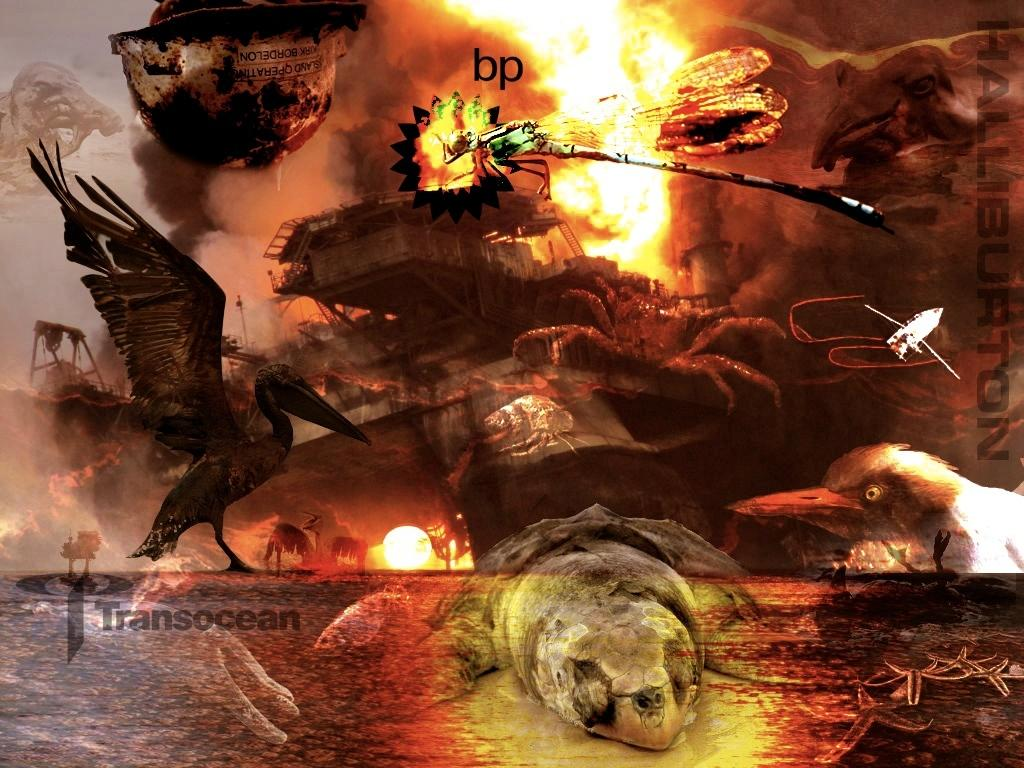What is the main subject of the image? The main subject of the image is a depiction of animals. Are there any noticeable features on the sides of the image? Yes, there are watermarks on the sides of the image. What type of chalk is being used to draw the animals in the image? There is no chalk present in the image, as it is a depiction of animals rather than a drawing. How does the spark from the animals' eyes light up the image? There are no sparks or glowing eyes in the image; it is a static depiction of animals. 